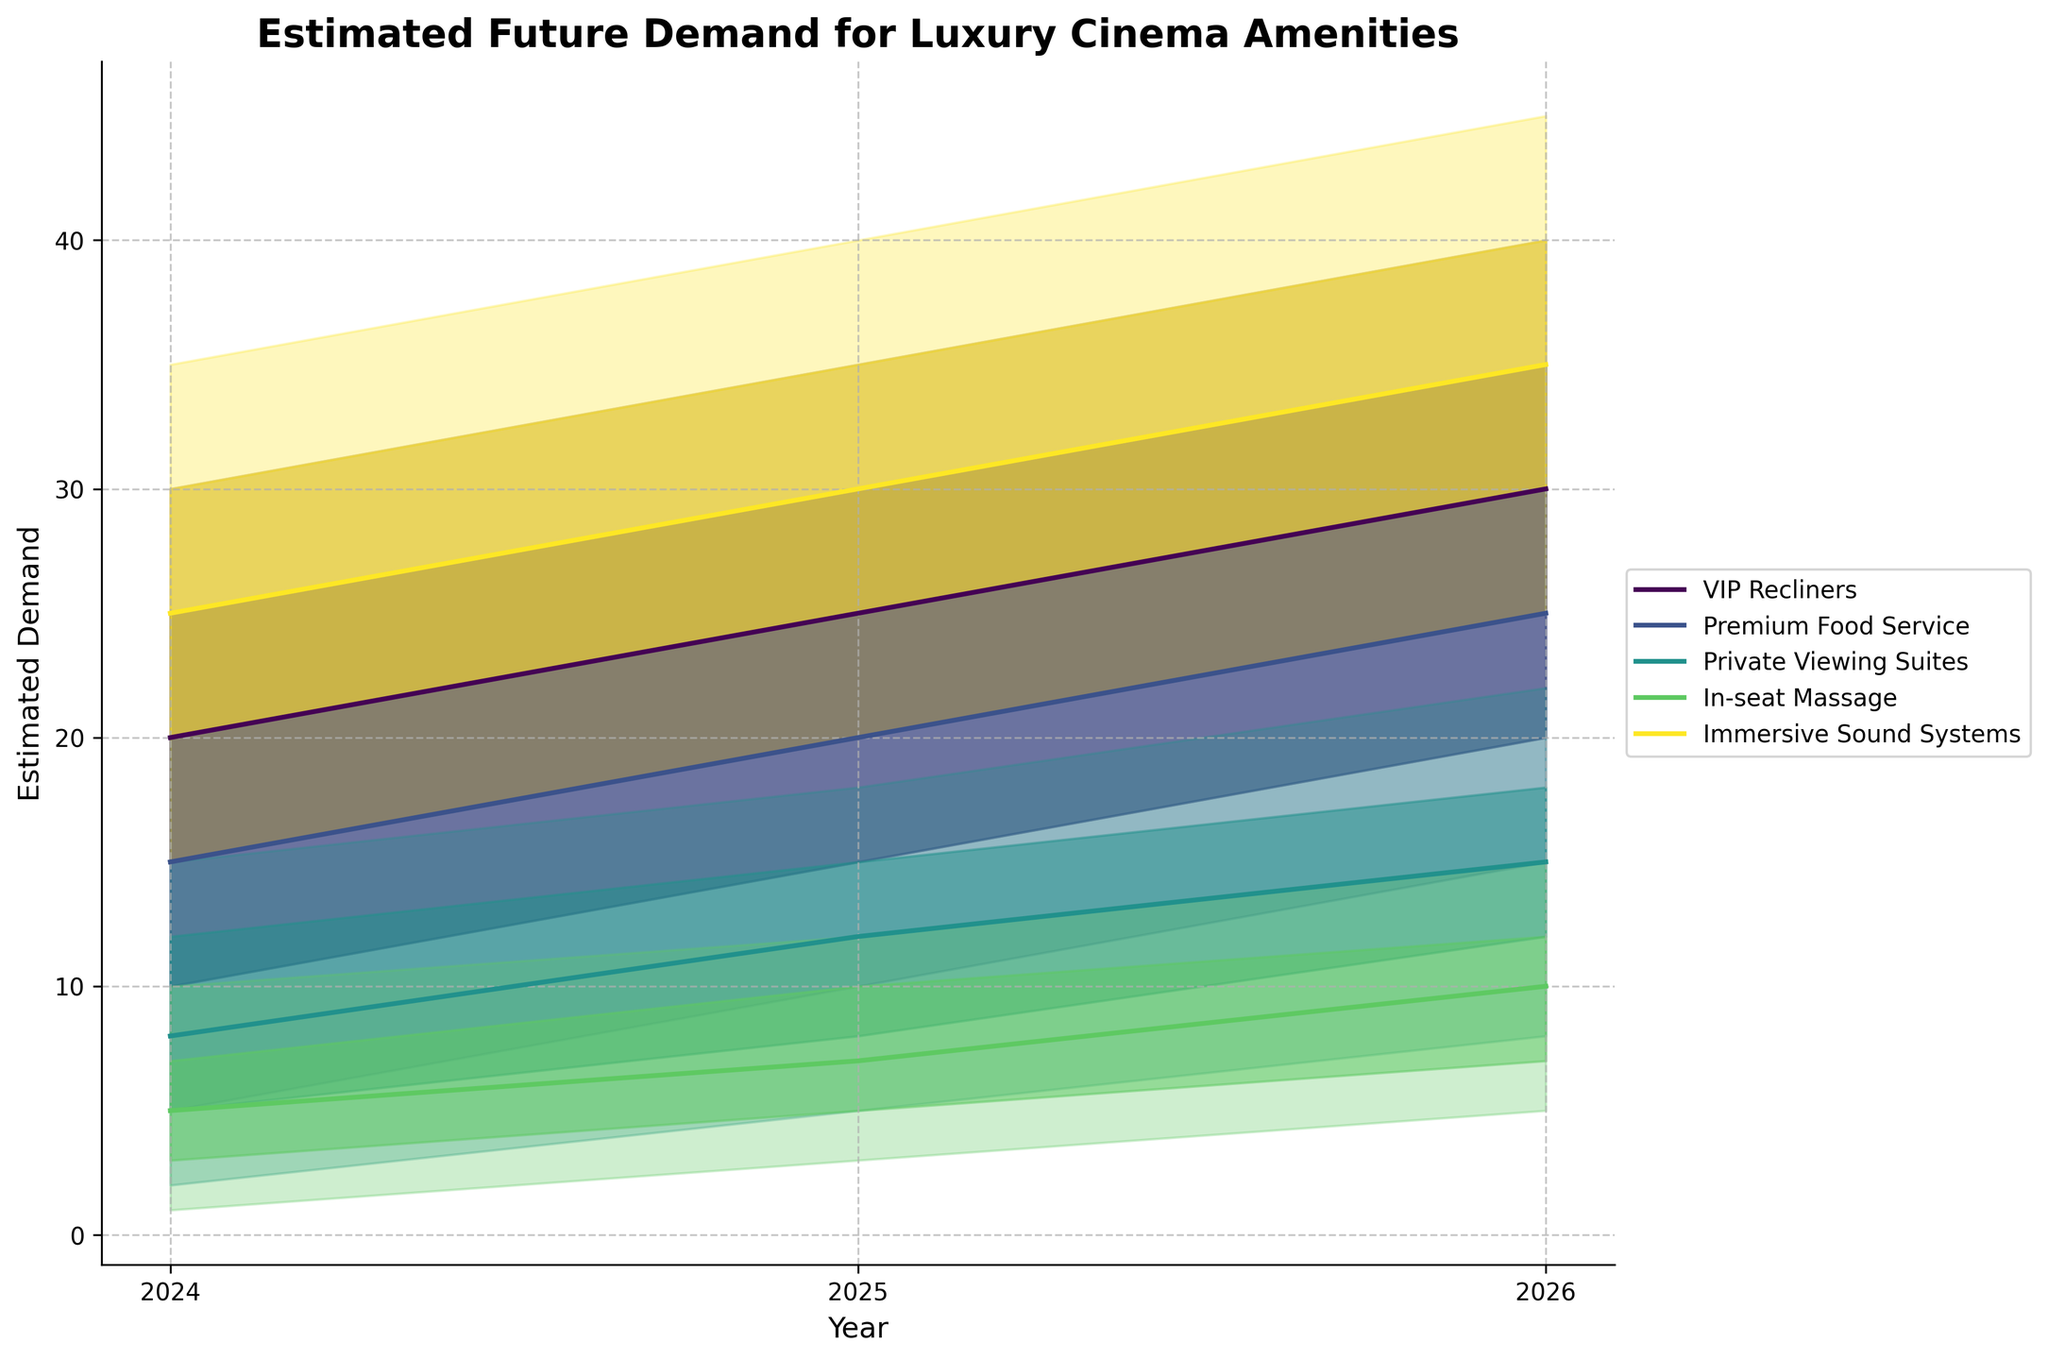What is the title of the figure? The title of the figure is shown at the top and is in bold.
Answer: Estimated Future Demand for Luxury Cinema Amenities What are the segments included in the figure? The segments are depicted by different lines or areas with distinct colors and are labeled in the legend.
Answer: VIP Recliners, Premium Food Service, Private Viewing Suites, In-seat Massage, Immersive Sound Systems Which segment has the highest estimated demand in 2026? Look for the segment with the highest "High" value in 2026 by tracing along the x-axis to the year 2026 and checking the upper boundaries of the shaded areas.
Answer: Immersive Sound Systems What is the expected range of demand for Premium Food Service in 2025? Find the Premium Food Service segment in the legend, follow its respective shaded area for the year 2025, and read the range between the "Low" and "High" boundaries.
Answer: 10 to 30 How does the mid-point of estimated demand for In-seat Massage change from 2024 to 2026? Trace the mid-point (central line) for In-seat Massage from 2024 to 2026 and describe the change in values.
Answer: It increases from 5 to 10 Comparing VIP Recliners and Private Viewing Suites, which segment shows a greater increase in the mid-point estimate from 2024 to 2026? Find the mid-point for both segments in 2024 and 2026, calculate the increase for each, and compare the differences.
Answer: VIP Recliners What is the range of estimated demand for Private Viewing Suites in 2026 according to the figure? Identify the shaded area for Private Viewing Suites in 2026 and note the "Low" and "High" values.
Answer: 8 to 22 Which segment has the most significant change in high estimate demand from 2024 to 2026? Compare the "High" estimates for all segments in 2024 and 2026 and determine which has the largest increase.
Answer: Immersive Sound Systems Between 2024 and 2025, which segment exhibits the least change in estimated mid-point demand? Calculate the change in mid-point values for each segment between these years and identify the smallest difference.
Answer: Private Viewing Suites 